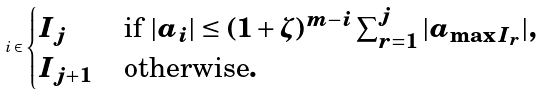<formula> <loc_0><loc_0><loc_500><loc_500>i \in \begin{cases} I _ { j } & \text {if $|a_{i}| \leq (1+ \zeta)^{m-i} \sum_{r=1}^{j} |a_{\max I_{r}}|$} , \\ I _ { j + 1 } \, & \text {otherwise} . \end{cases}</formula> 